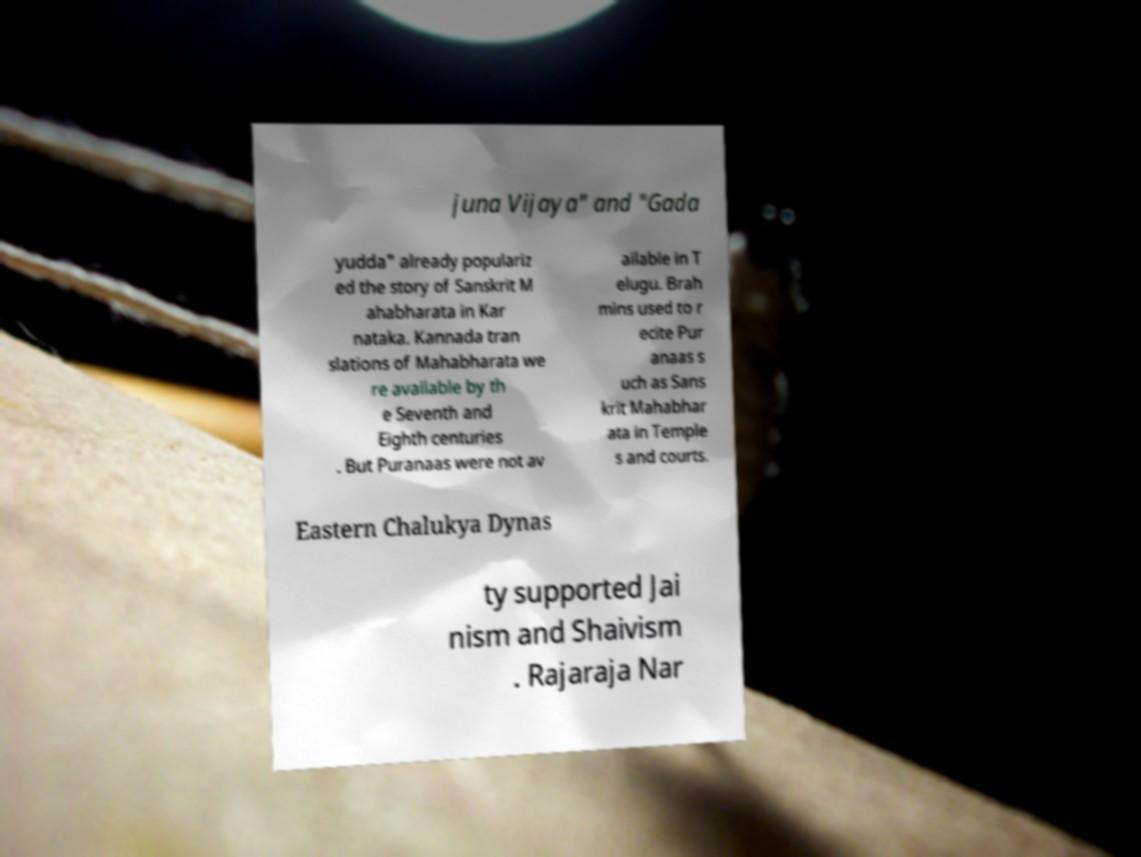Could you extract and type out the text from this image? juna Vijaya" and "Gada yudda" already populariz ed the story of Sanskrit M ahabharata in Kar nataka. Kannada tran slations of Mahabharata we re available by th e Seventh and Eighth centuries . But Puranaas were not av ailable in T elugu. Brah mins used to r ecite Pur anaas s uch as Sans krit Mahabhar ata in Temple s and courts. Eastern Chalukya Dynas ty supported Jai nism and Shaivism . Rajaraja Nar 